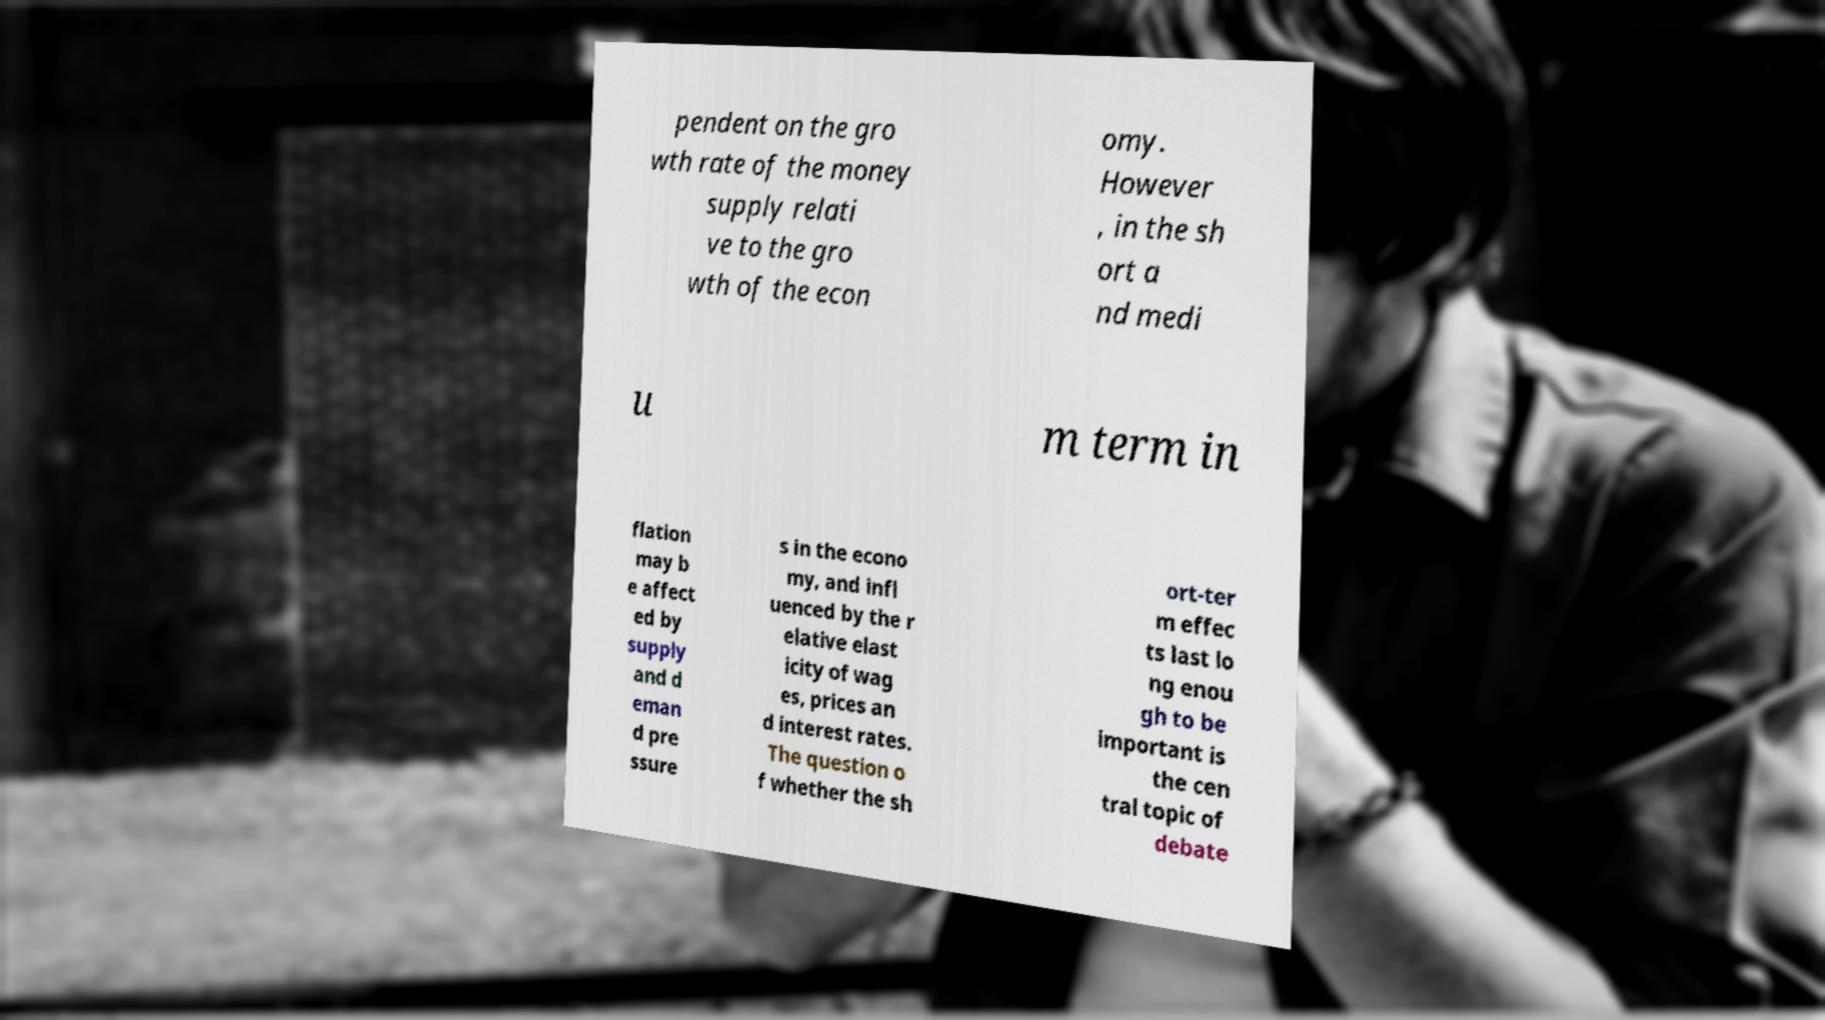There's text embedded in this image that I need extracted. Can you transcribe it verbatim? pendent on the gro wth rate of the money supply relati ve to the gro wth of the econ omy. However , in the sh ort a nd medi u m term in flation may b e affect ed by supply and d eman d pre ssure s in the econo my, and infl uenced by the r elative elast icity of wag es, prices an d interest rates. The question o f whether the sh ort-ter m effec ts last lo ng enou gh to be important is the cen tral topic of debate 